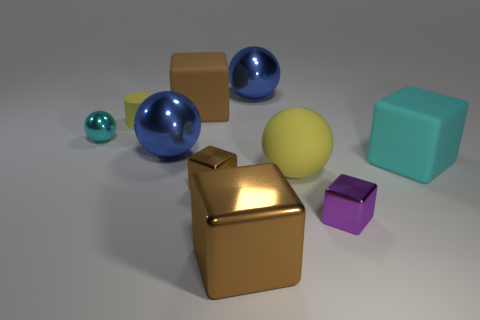How many blue balls must be subtracted to get 1 blue balls? 1 Subtract all cyan cylinders. How many brown blocks are left? 3 Subtract all cyan cubes. How many cubes are left? 4 Subtract all purple cubes. How many cubes are left? 4 Subtract all red cylinders. Subtract all gray cubes. How many cylinders are left? 1 Subtract all cylinders. How many objects are left? 9 Add 3 small purple rubber spheres. How many small purple rubber spheres exist? 3 Subtract 0 brown spheres. How many objects are left? 10 Subtract all tiny yellow cylinders. Subtract all brown metal blocks. How many objects are left? 7 Add 4 big things. How many big things are left? 10 